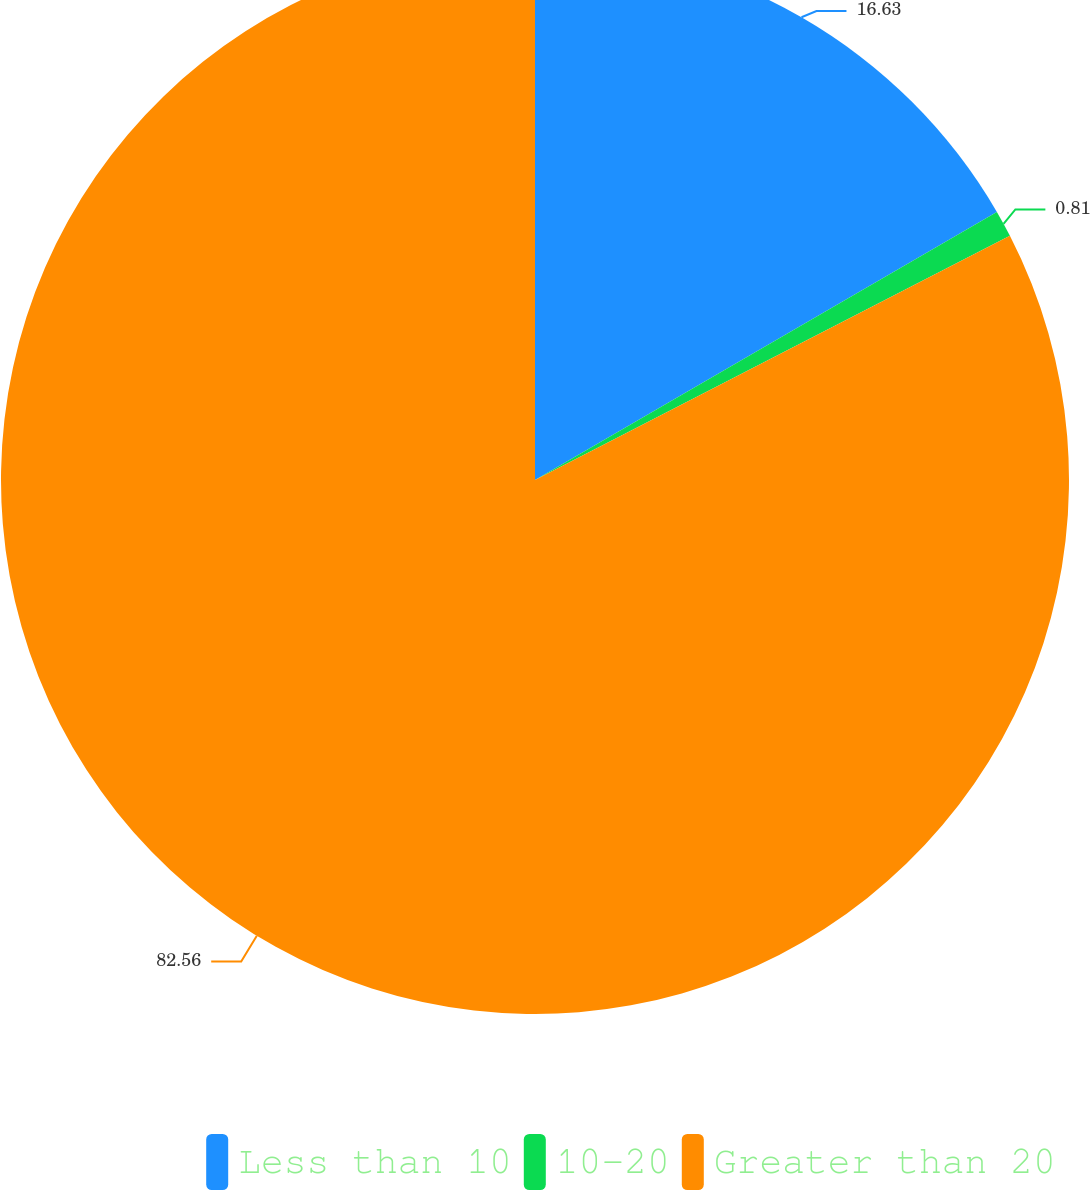Convert chart. <chart><loc_0><loc_0><loc_500><loc_500><pie_chart><fcel>Less than 10<fcel>10-20<fcel>Greater than 20<nl><fcel>16.63%<fcel>0.81%<fcel>82.55%<nl></chart> 